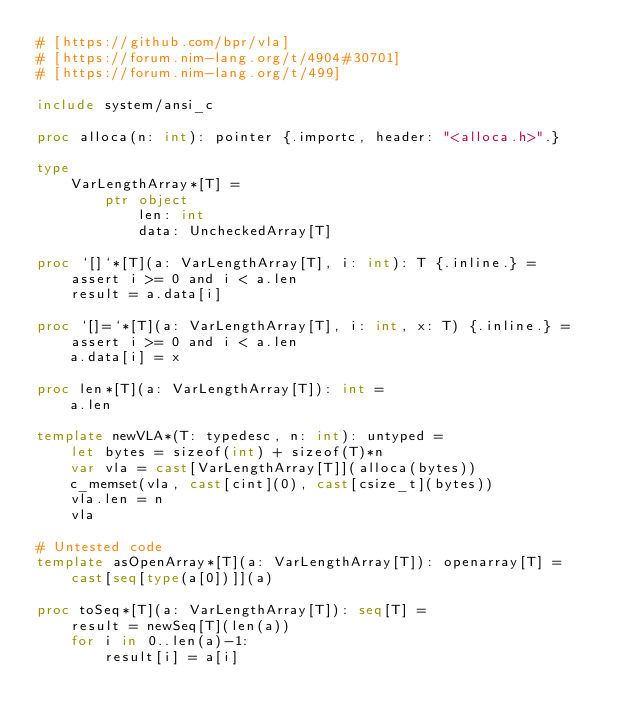<code> <loc_0><loc_0><loc_500><loc_500><_Nim_># [https://github.com/bpr/vla]
# [https://forum.nim-lang.org/t/4904#30701]
# [https://forum.nim-lang.org/t/499]

include system/ansi_c

proc alloca(n: int): pointer {.importc, header: "<alloca.h>".}

type
    VarLengthArray*[T] =
        ptr object
            len: int
            data: UncheckedArray[T]

proc `[]`*[T](a: VarLengthArray[T], i: int): T {.inline.} =
    assert i >= 0 and i < a.len
    result = a.data[i]

proc `[]=`*[T](a: VarLengthArray[T], i: int, x: T) {.inline.} =
    assert i >= 0 and i < a.len
    a.data[i] = x

proc len*[T](a: VarLengthArray[T]): int =
    a.len

template newVLA*(T: typedesc, n: int): untyped =
    let bytes = sizeof(int) + sizeof(T)*n
    var vla = cast[VarLengthArray[T]](alloca(bytes))
    c_memset(vla, cast[cint](0), cast[csize_t](bytes))
    vla.len = n
    vla

# Untested code
template asOpenArray*[T](a: VarLengthArray[T]): openarray[T] =
    cast[seq[type(a[0])]](a)

proc toSeq*[T](a: VarLengthArray[T]): seq[T] =
    result = newSeq[T](len(a))
    for i in 0..len(a)-1:
        result[i] = a[i]
</code> 